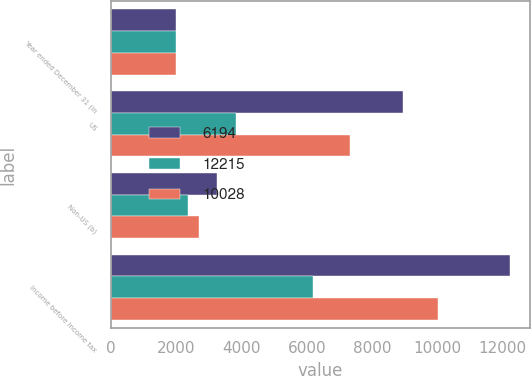Convert chart to OTSL. <chart><loc_0><loc_0><loc_500><loc_500><stacked_bar_chart><ecel><fcel>Year ended December 31 (in<fcel>US<fcel>Non-US (b)<fcel>Income before income tax<nl><fcel>6194<fcel>2005<fcel>8959<fcel>3256<fcel>12215<nl><fcel>12215<fcel>2004<fcel>3817<fcel>2377<fcel>6194<nl><fcel>10028<fcel>2003<fcel>7333<fcel>2695<fcel>10028<nl></chart> 